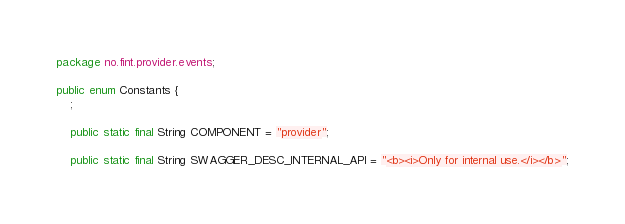<code> <loc_0><loc_0><loc_500><loc_500><_Java_>package no.fint.provider.events;

public enum Constants {
    ;

    public static final String COMPONENT = "provider";

    public static final String SWAGGER_DESC_INTERNAL_API = "<b><i>Only for internal use.</i></b>";</code> 